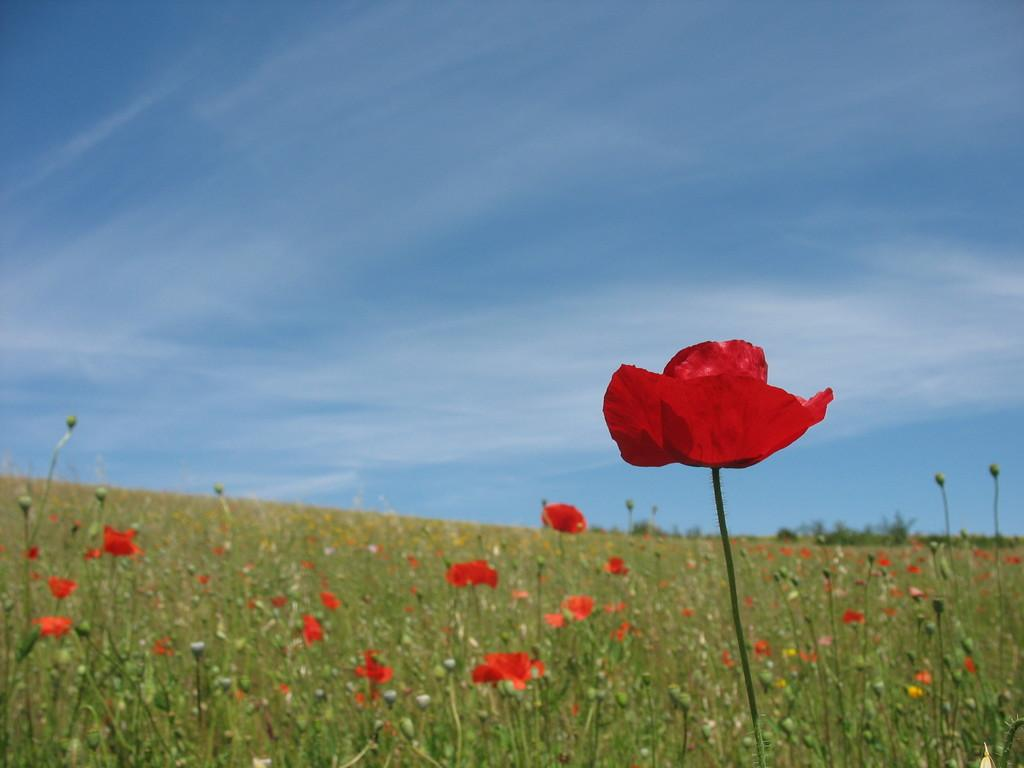What type of living organisms are present in the image? There are plants in the image. What stage of growth are the plants in? The plants have buds and flowers, indicating that they are in a blooming stage. What can be seen in the background of the image? The sky is visible at the top of the image. What type of juice is being sold by the beggar in the image? There is no beggar or juice present in the image; it features plants with buds and flowers. What disease affects the plants in the image? There is no indication of any disease affecting the plants in the image. 